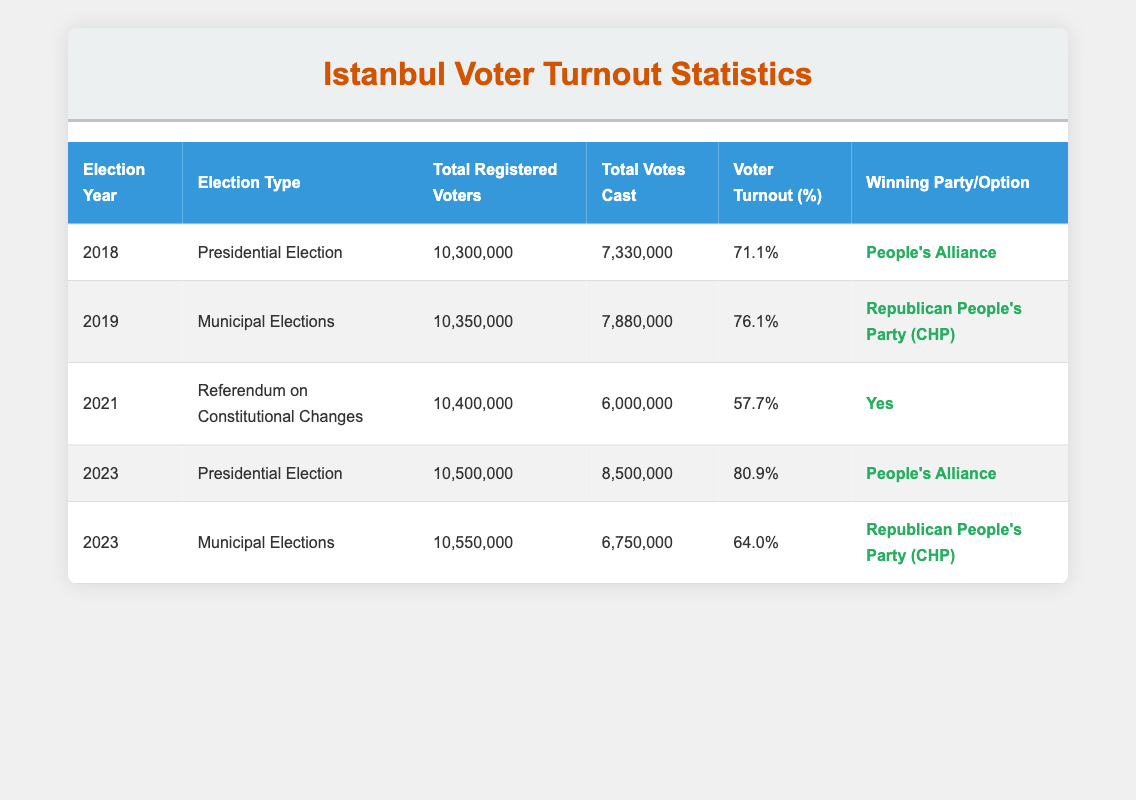What was the voter turnout percentage in the 2019 Municipal Elections? In the table, under the row for the 2019 Municipal Elections, the voter turnout percentage is clearly listed as 76.1%.
Answer: 76.1% Which election had the highest voter turnout percentage? By comparing the voter turnout percentages across all the elections, the 2023 Presidential Election had the highest percentage at 80.9%.
Answer: 80.9% What was the total number of registered voters for the 2021 referendum? The table shows that for the 2021 referendum on constitutional changes, the total number of registered voters was 10,400,000.
Answer: 10,400,000 How many more votes were cast in the 2023 Presidential Election compared to the 2023 Municipal Elections? The total votes cast in the 2023 Presidential Election was 8,500,000, and in the 2023 Municipal Elections, it was 6,750,000. So, the difference is 8,500,000 - 6,750,000 = 1,750,000.
Answer: 1,750,000 Did the People's Alliance win the Municipal Elections in 2023? The table indicates that in the 2023 Municipal Elections, the winning party was the Republican People's Party (CHP), which means the People's Alliance did not win.
Answer: No What is the average voter turnout percentage for all elections listed in the table? The voter turnout percentages are 71.1%, 76.1%, 57.7%, 80.9%, and 64.0%. To find the average, sum these percentages: 71.1 + 76.1 + 57.7 + 80.9 + 64.0 = 349.0. Then divide by the number of elections: 349.0 / 5 = 69.8.
Answer: 69.8 How many registered voters were there in total across all elections in the table? The total registered voters for each election are 10,300,000, 10,350,000, 10,400,000, 10,500,000, and 10,550,000. Summing these gives 10,300,000 + 10,350,000 + 10,400,000 + 10,500,000 + 10,550,000 = 52,100,000.
Answer: 52,100,000 Which election had the lowest voter turnout percentage and what was it? Looking through the table, the 2021 referendum on constitutional changes had the lowest voter turnout percentage, listed as 57.7%.
Answer: 57.7% 